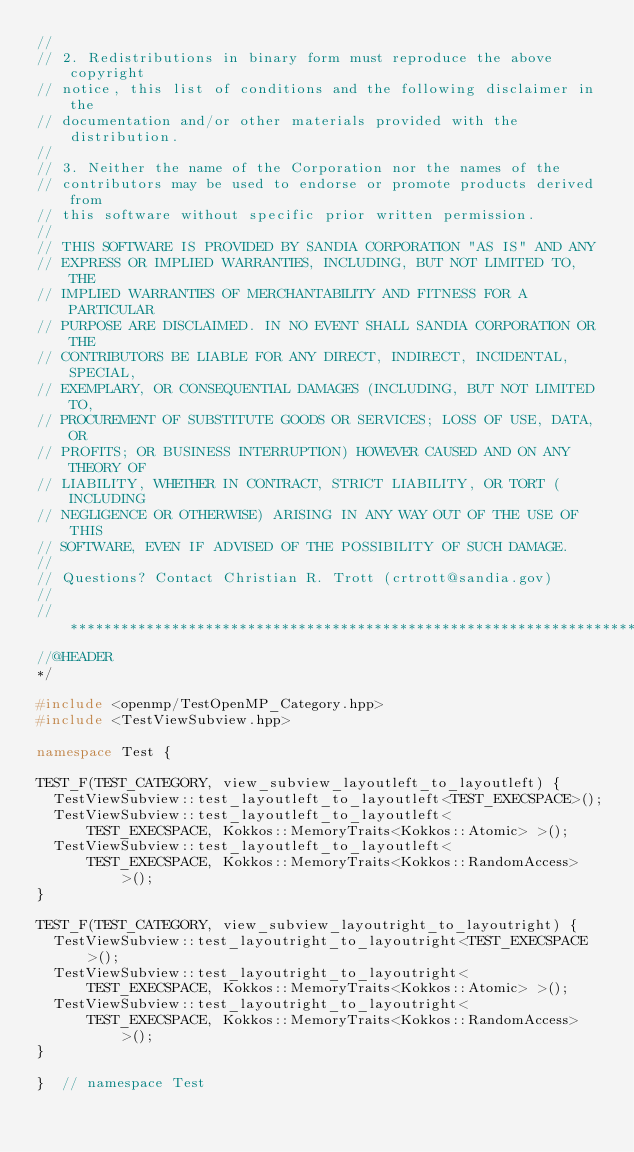Convert code to text. <code><loc_0><loc_0><loc_500><loc_500><_C++_>//
// 2. Redistributions in binary form must reproduce the above copyright
// notice, this list of conditions and the following disclaimer in the
// documentation and/or other materials provided with the distribution.
//
// 3. Neither the name of the Corporation nor the names of the
// contributors may be used to endorse or promote products derived from
// this software without specific prior written permission.
//
// THIS SOFTWARE IS PROVIDED BY SANDIA CORPORATION "AS IS" AND ANY
// EXPRESS OR IMPLIED WARRANTIES, INCLUDING, BUT NOT LIMITED TO, THE
// IMPLIED WARRANTIES OF MERCHANTABILITY AND FITNESS FOR A PARTICULAR
// PURPOSE ARE DISCLAIMED. IN NO EVENT SHALL SANDIA CORPORATION OR THE
// CONTRIBUTORS BE LIABLE FOR ANY DIRECT, INDIRECT, INCIDENTAL, SPECIAL,
// EXEMPLARY, OR CONSEQUENTIAL DAMAGES (INCLUDING, BUT NOT LIMITED TO,
// PROCUREMENT OF SUBSTITUTE GOODS OR SERVICES; LOSS OF USE, DATA, OR
// PROFITS; OR BUSINESS INTERRUPTION) HOWEVER CAUSED AND ON ANY THEORY OF
// LIABILITY, WHETHER IN CONTRACT, STRICT LIABILITY, OR TORT (INCLUDING
// NEGLIGENCE OR OTHERWISE) ARISING IN ANY WAY OUT OF THE USE OF THIS
// SOFTWARE, EVEN IF ADVISED OF THE POSSIBILITY OF SUCH DAMAGE.
//
// Questions? Contact Christian R. Trott (crtrott@sandia.gov)
//
// ************************************************************************
//@HEADER
*/

#include <openmp/TestOpenMP_Category.hpp>
#include <TestViewSubview.hpp>

namespace Test {

TEST_F(TEST_CATEGORY, view_subview_layoutleft_to_layoutleft) {
  TestViewSubview::test_layoutleft_to_layoutleft<TEST_EXECSPACE>();
  TestViewSubview::test_layoutleft_to_layoutleft<
      TEST_EXECSPACE, Kokkos::MemoryTraits<Kokkos::Atomic> >();
  TestViewSubview::test_layoutleft_to_layoutleft<
      TEST_EXECSPACE, Kokkos::MemoryTraits<Kokkos::RandomAccess> >();
}

TEST_F(TEST_CATEGORY, view_subview_layoutright_to_layoutright) {
  TestViewSubview::test_layoutright_to_layoutright<TEST_EXECSPACE>();
  TestViewSubview::test_layoutright_to_layoutright<
      TEST_EXECSPACE, Kokkos::MemoryTraits<Kokkos::Atomic> >();
  TestViewSubview::test_layoutright_to_layoutright<
      TEST_EXECSPACE, Kokkos::MemoryTraits<Kokkos::RandomAccess> >();
}

}  // namespace Test
</code> 